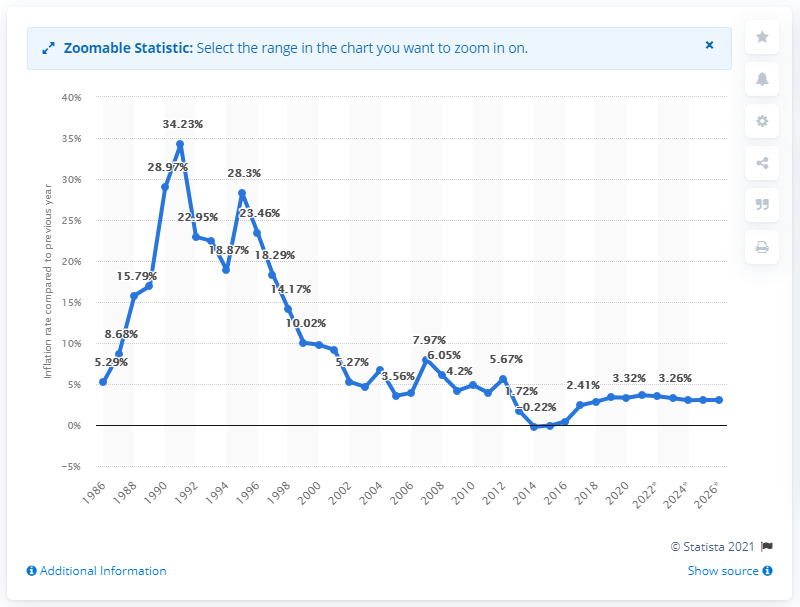List a handful of essential elements in this visual. The inflation rate in Hungary in 2020 was 3.32%. 